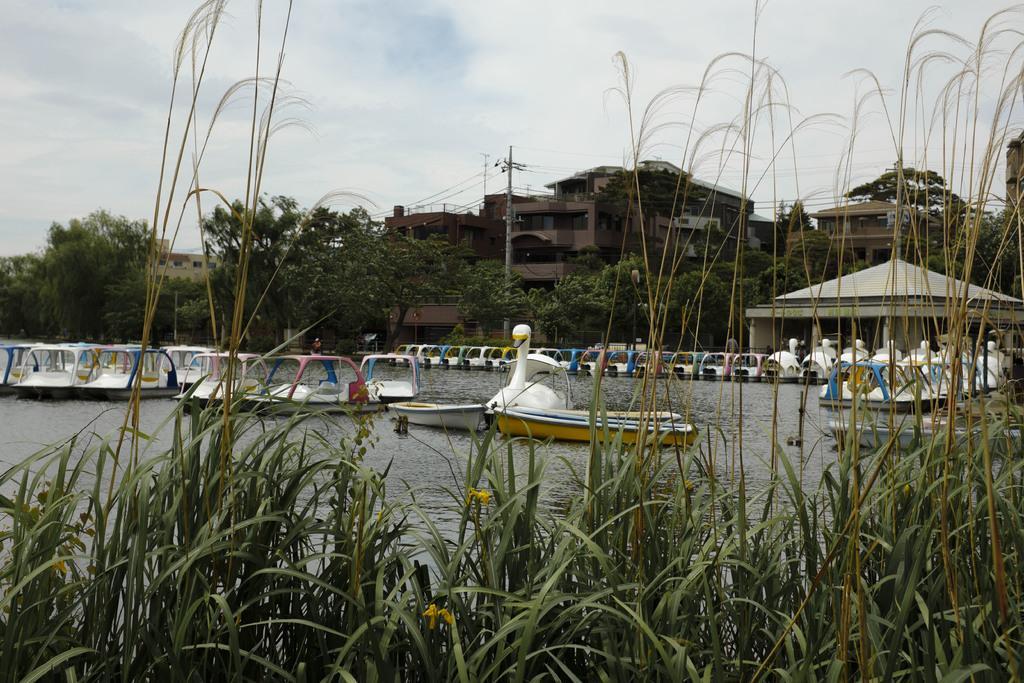Could you give a brief overview of what you see in this image? In this image I can see few boats on the water. In the background I can see few trees in green color, an electric pole, few buildings and the sky is in blue and white color. 